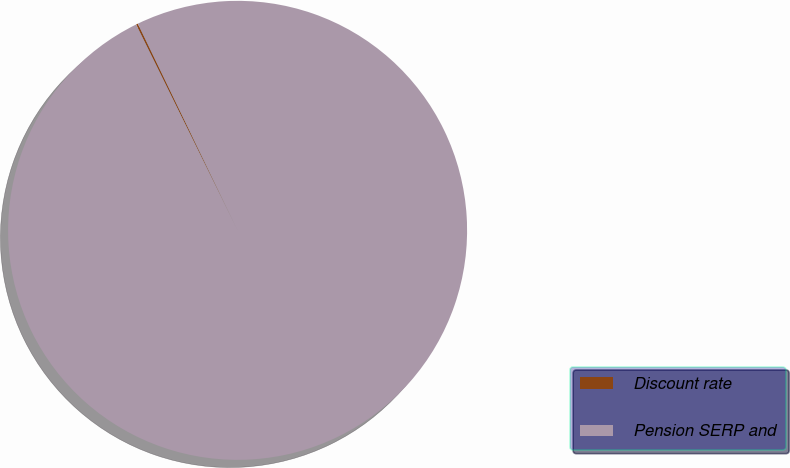Convert chart. <chart><loc_0><loc_0><loc_500><loc_500><pie_chart><fcel>Discount rate<fcel>Pension SERP and<nl><fcel>0.13%<fcel>99.87%<nl></chart> 